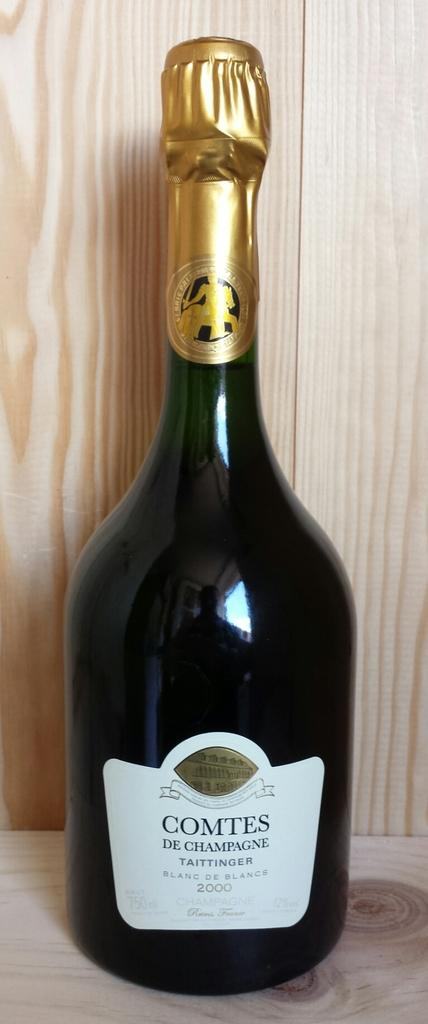<image>
Relay a brief, clear account of the picture shown. bottle of comtes de champagne against a wood background 